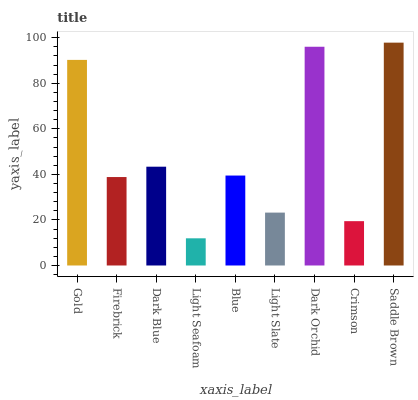Is Light Seafoam the minimum?
Answer yes or no. Yes. Is Saddle Brown the maximum?
Answer yes or no. Yes. Is Firebrick the minimum?
Answer yes or no. No. Is Firebrick the maximum?
Answer yes or no. No. Is Gold greater than Firebrick?
Answer yes or no. Yes. Is Firebrick less than Gold?
Answer yes or no. Yes. Is Firebrick greater than Gold?
Answer yes or no. No. Is Gold less than Firebrick?
Answer yes or no. No. Is Blue the high median?
Answer yes or no. Yes. Is Blue the low median?
Answer yes or no. Yes. Is Dark Blue the high median?
Answer yes or no. No. Is Dark Orchid the low median?
Answer yes or no. No. 